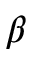Convert formula to latex. <formula><loc_0><loc_0><loc_500><loc_500>\beta</formula> 